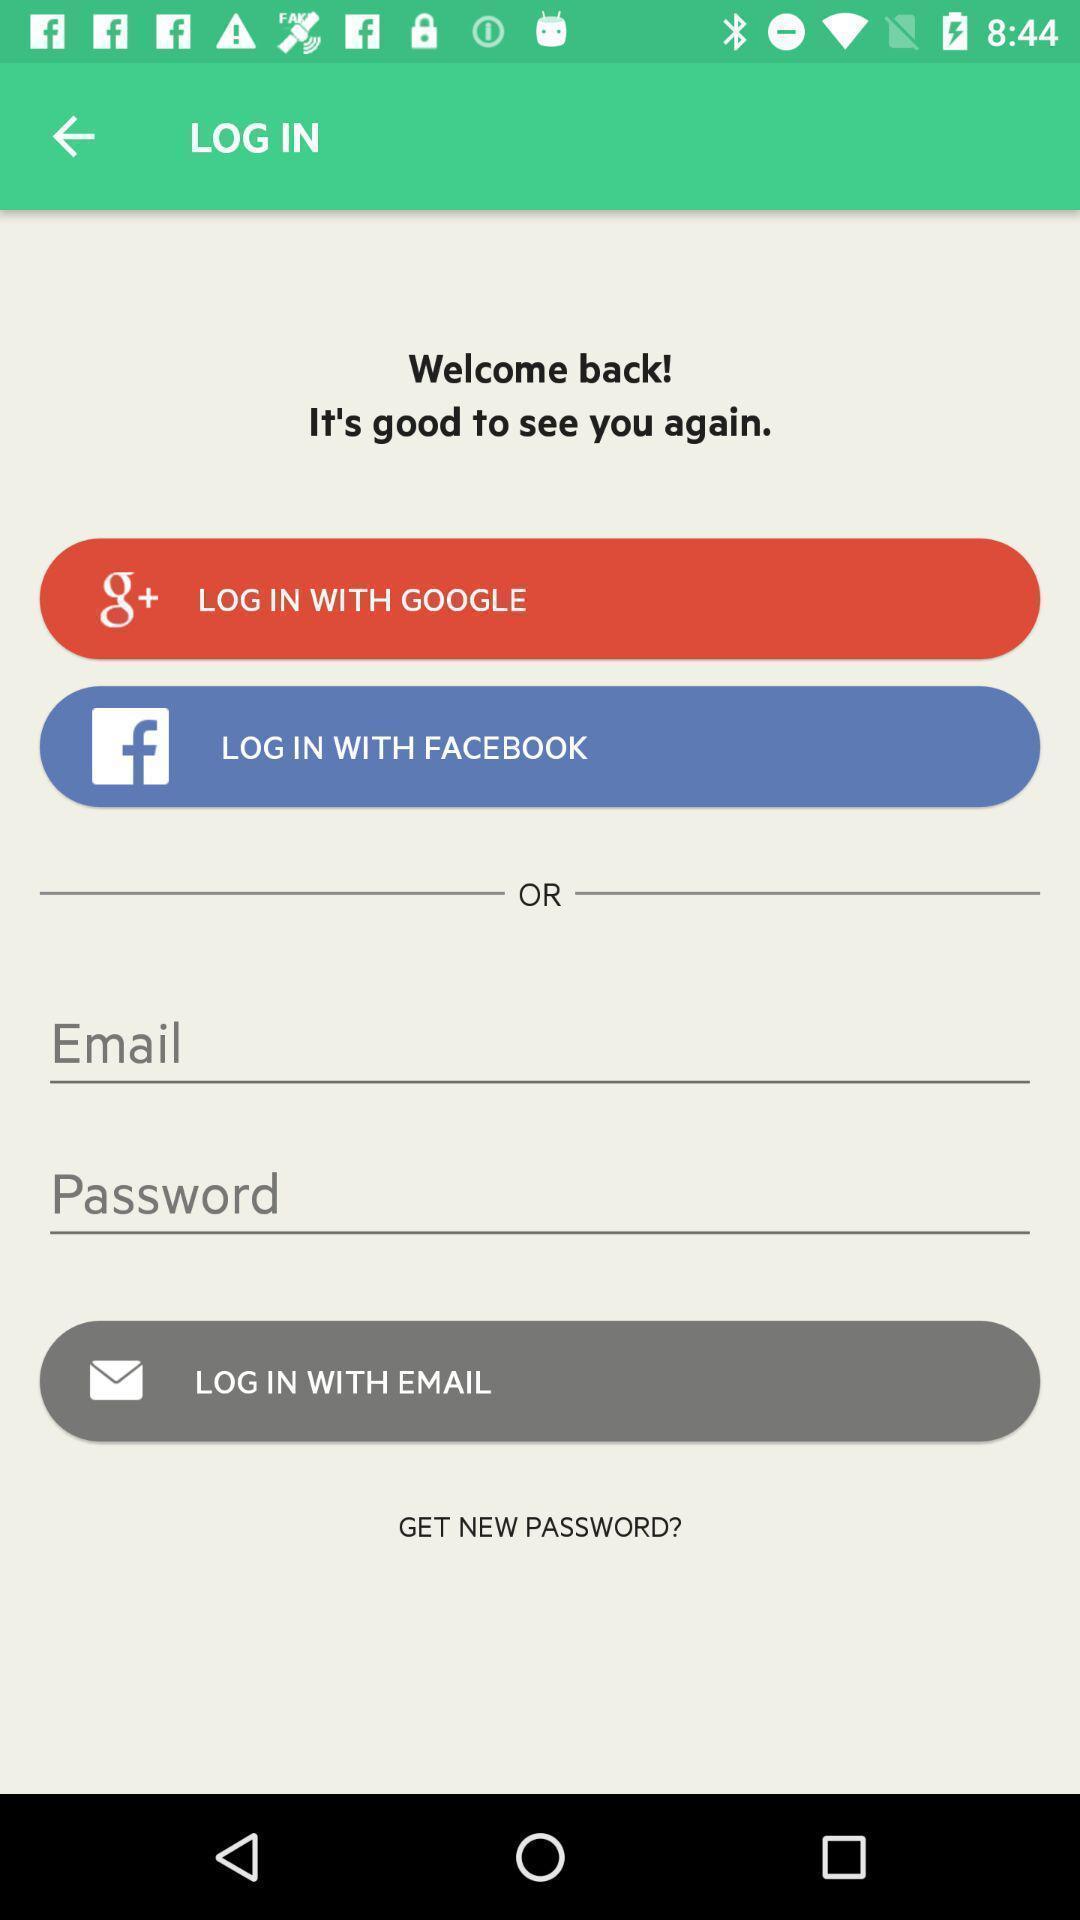Provide a description of this screenshot. Login page. 